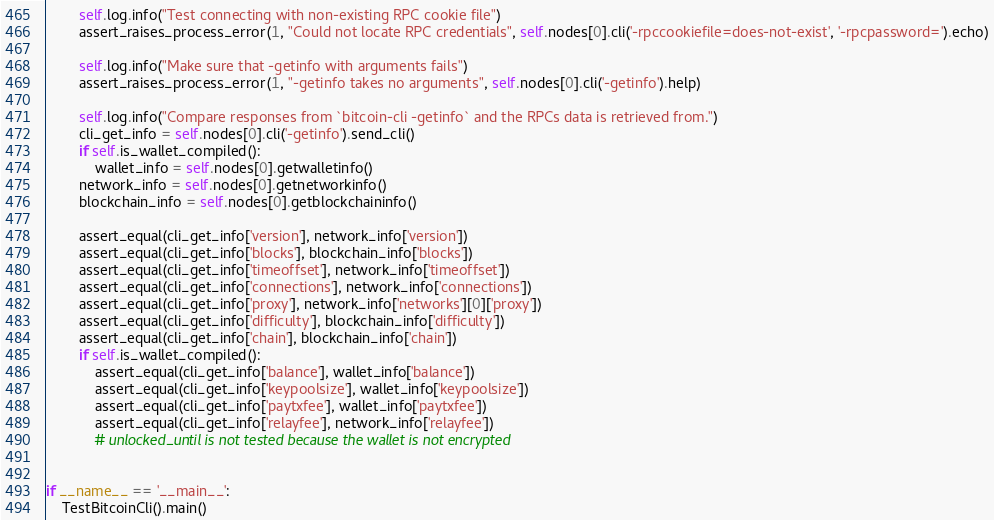Convert code to text. <code><loc_0><loc_0><loc_500><loc_500><_Python_>        self.log.info("Test connecting with non-existing RPC cookie file")
        assert_raises_process_error(1, "Could not locate RPC credentials", self.nodes[0].cli('-rpccookiefile=does-not-exist', '-rpcpassword=').echo)

        self.log.info("Make sure that -getinfo with arguments fails")
        assert_raises_process_error(1, "-getinfo takes no arguments", self.nodes[0].cli('-getinfo').help)

        self.log.info("Compare responses from `bitcoin-cli -getinfo` and the RPCs data is retrieved from.")
        cli_get_info = self.nodes[0].cli('-getinfo').send_cli()
        if self.is_wallet_compiled():
            wallet_info = self.nodes[0].getwalletinfo()
        network_info = self.nodes[0].getnetworkinfo()
        blockchain_info = self.nodes[0].getblockchaininfo()

        assert_equal(cli_get_info['version'], network_info['version'])
        assert_equal(cli_get_info['blocks'], blockchain_info['blocks'])
        assert_equal(cli_get_info['timeoffset'], network_info['timeoffset'])
        assert_equal(cli_get_info['connections'], network_info['connections'])
        assert_equal(cli_get_info['proxy'], network_info['networks'][0]['proxy'])
        assert_equal(cli_get_info['difficulty'], blockchain_info['difficulty'])
        assert_equal(cli_get_info['chain'], blockchain_info['chain'])
        if self.is_wallet_compiled():
            assert_equal(cli_get_info['balance'], wallet_info['balance'])
            assert_equal(cli_get_info['keypoolsize'], wallet_info['keypoolsize'])
            assert_equal(cli_get_info['paytxfee'], wallet_info['paytxfee'])
            assert_equal(cli_get_info['relayfee'], network_info['relayfee'])
            # unlocked_until is not tested because the wallet is not encrypted


if __name__ == '__main__':
    TestBitcoinCli().main()
</code> 